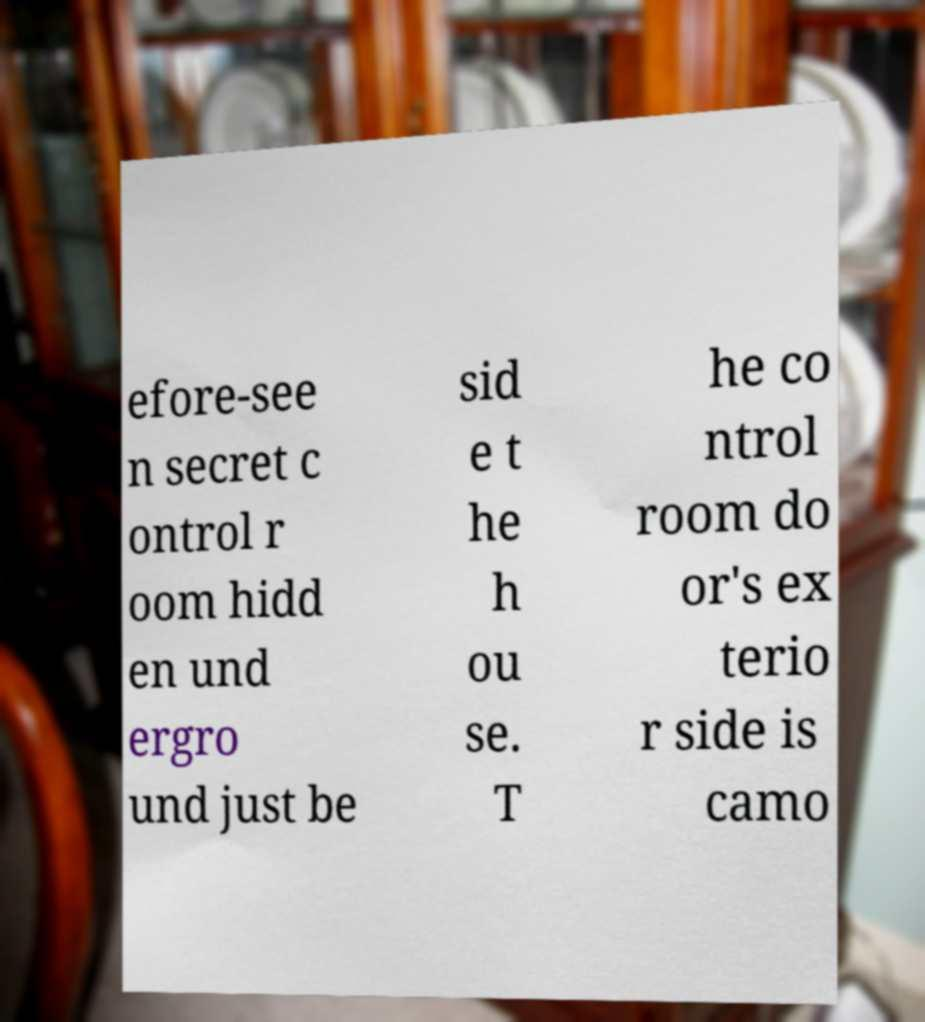For documentation purposes, I need the text within this image transcribed. Could you provide that? efore-see n secret c ontrol r oom hidd en und ergro und just be sid e t he h ou se. T he co ntrol room do or's ex terio r side is camo 